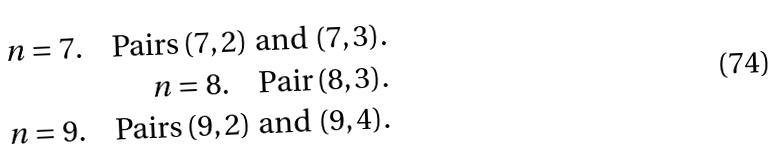Convert formula to latex. <formula><loc_0><loc_0><loc_500><loc_500>n = 7 . \quad \text {Pairs} \, ( 7 , 2 ) \text { and } ( 7 , 3 ) . \\ n = 8 . \quad \text {Pair} \, ( 8 , 3 ) . \\ n = 9 . \quad \text {Pairs} \, ( 9 , 2 ) \text { and } ( 9 , 4 ) .</formula> 